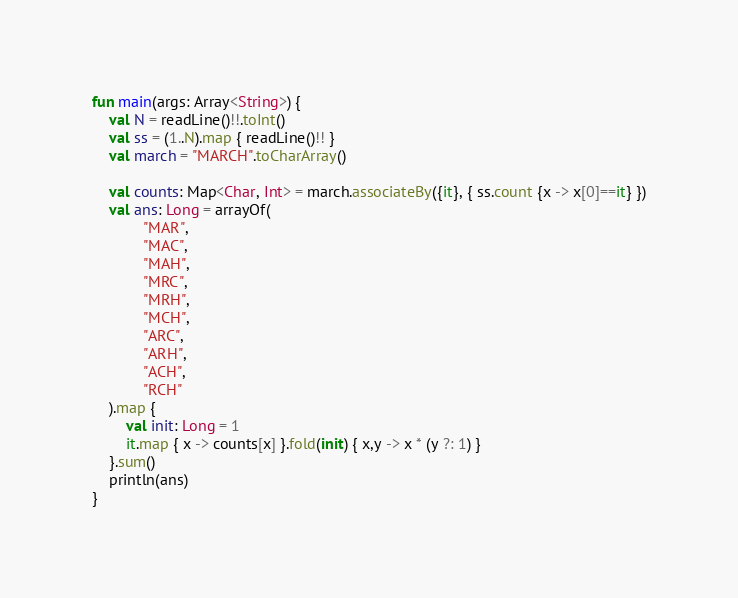<code> <loc_0><loc_0><loc_500><loc_500><_Kotlin_>
fun main(args: Array<String>) {
    val N = readLine()!!.toInt()
    val ss = (1..N).map { readLine()!! }
    val march = "MARCH".toCharArray()

    val counts: Map<Char, Int> = march.associateBy({it}, { ss.count {x -> x[0]==it} })
    val ans: Long = arrayOf(
            "MAR",
            "MAC",
            "MAH",
            "MRC",
            "MRH",
            "MCH",
            "ARC",
            "ARH",
            "ACH",
            "RCH"
    ).map {
        val init: Long = 1
        it.map { x -> counts[x] }.fold(init) { x,y -> x * (y ?: 1) }
    }.sum()
    println(ans)
}</code> 